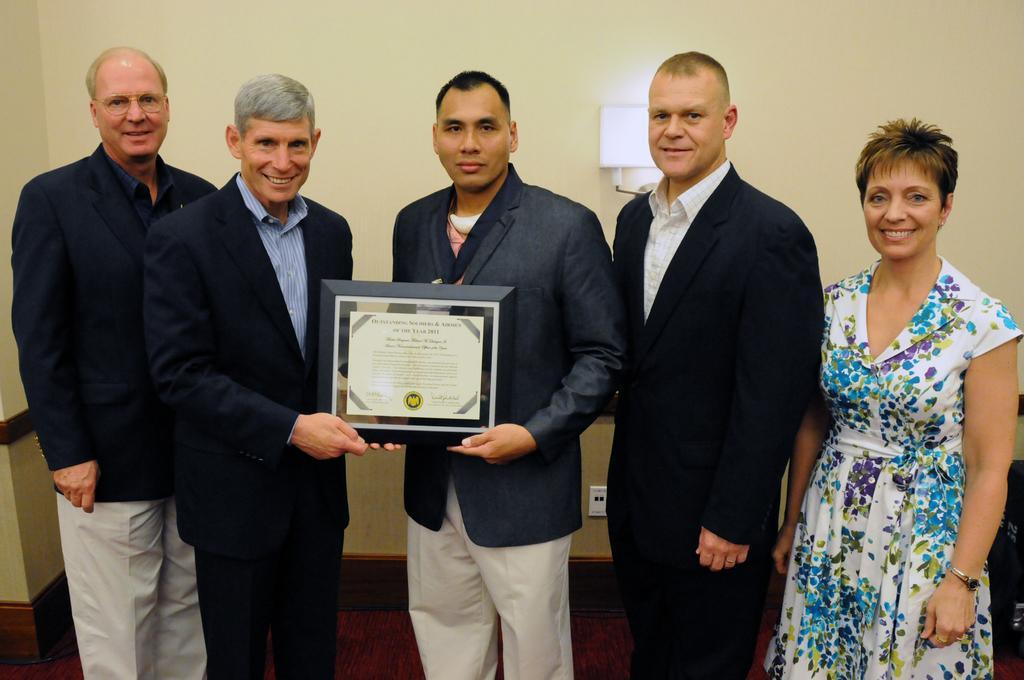Could you give a brief overview of what you see in this image? In this image there are some people who are standing and smiling, and two of them holding some shield and in the background there is a wall. At the bottom there is floor. 